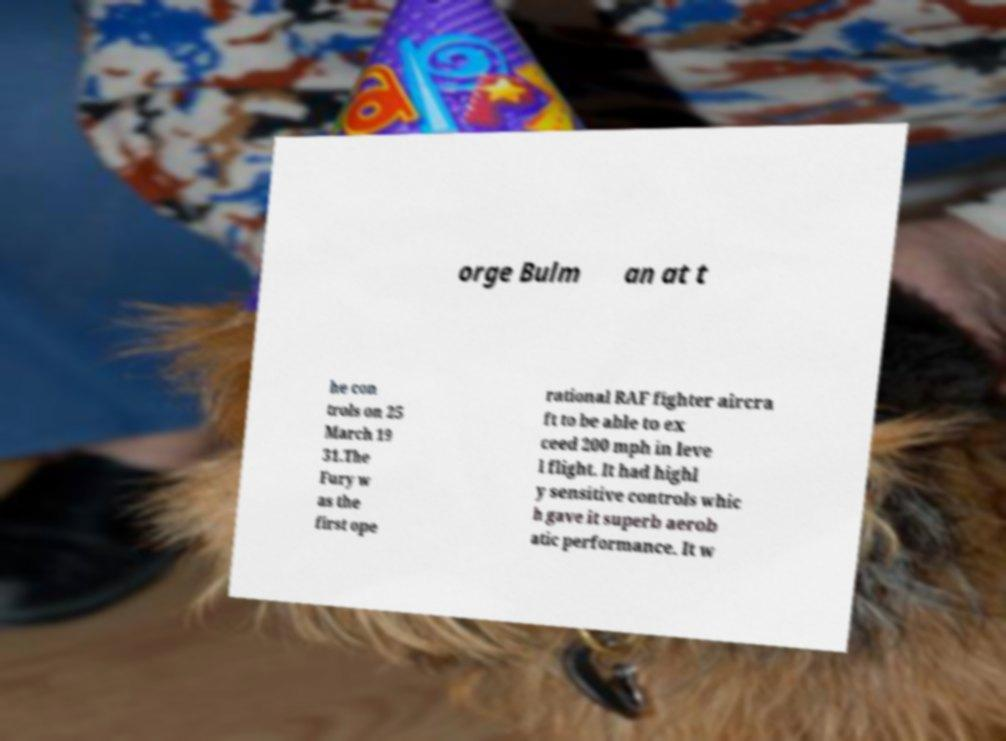Can you accurately transcribe the text from the provided image for me? orge Bulm an at t he con trols on 25 March 19 31.The Fury w as the first ope rational RAF fighter aircra ft to be able to ex ceed 200 mph in leve l flight. It had highl y sensitive controls whic h gave it superb aerob atic performance. It w 